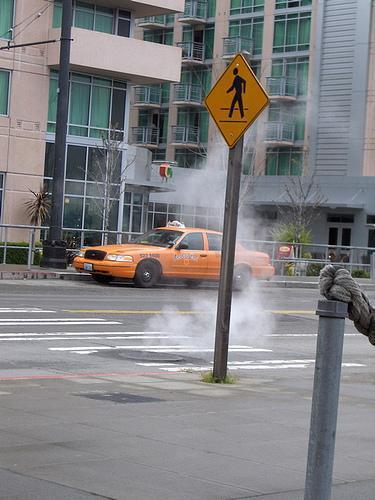How many people have cameras?
Give a very brief answer. 0. 